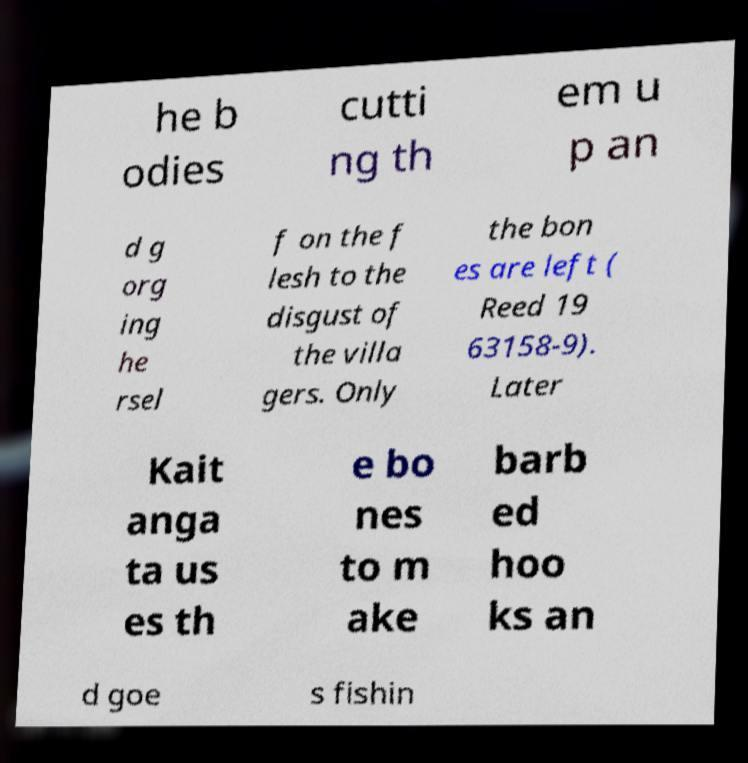What messages or text are displayed in this image? I need them in a readable, typed format. he b odies cutti ng th em u p an d g org ing he rsel f on the f lesh to the disgust of the villa gers. Only the bon es are left ( Reed 19 63158-9). Later Kait anga ta us es th e bo nes to m ake barb ed hoo ks an d goe s fishin 